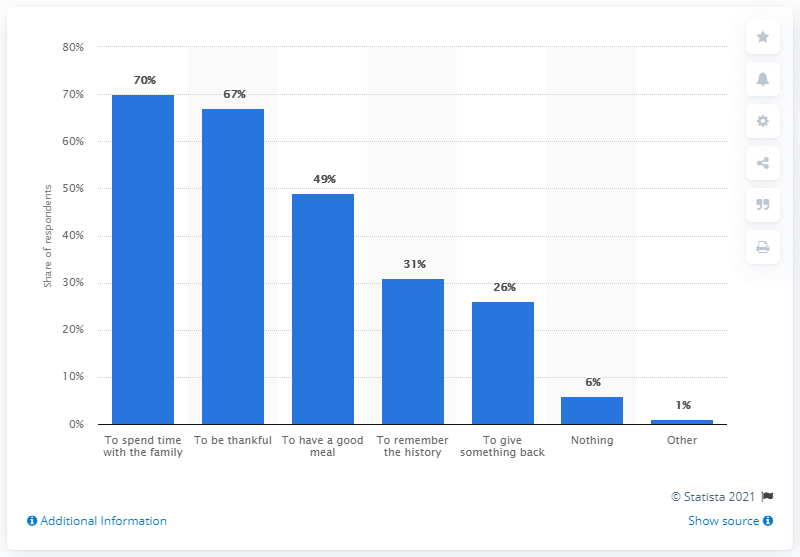Point out several critical features in this image. Spending time with one's family is undoubtedly the most valuable opinion one can have. The sum of two numbers, when combined, results in a percentage of 7% [Nothing, Other]. 